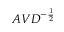<formula> <loc_0><loc_0><loc_500><loc_500>A V D ^ { - { \frac { 1 } { 2 } } }</formula> 